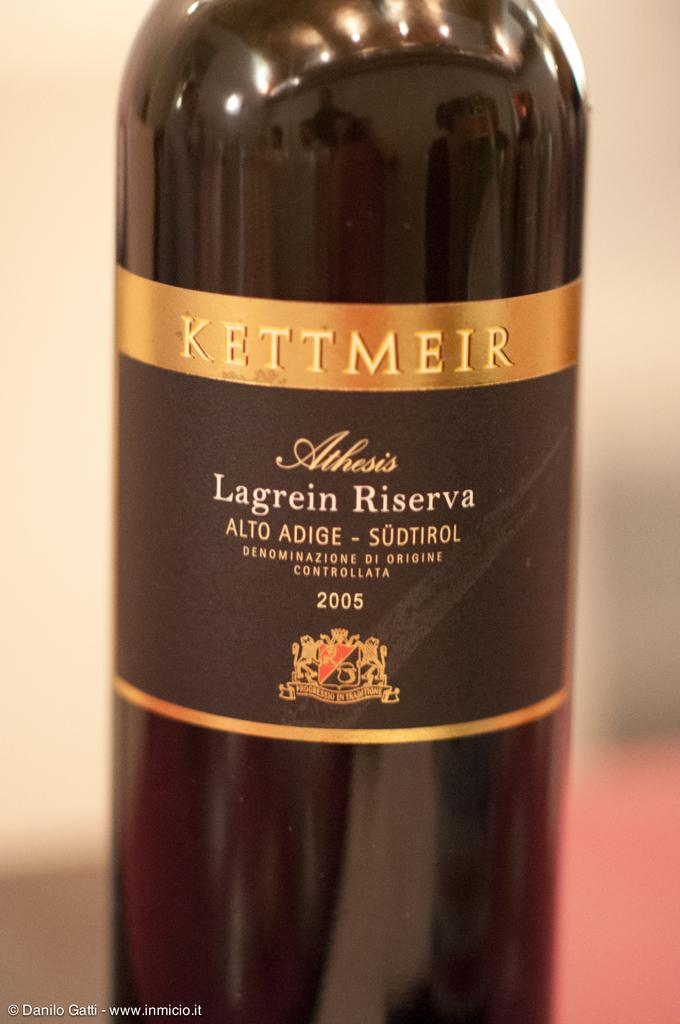<image>
Provide a brief description of the given image. A bottle with a gold and black label reads "Kettmeir." 